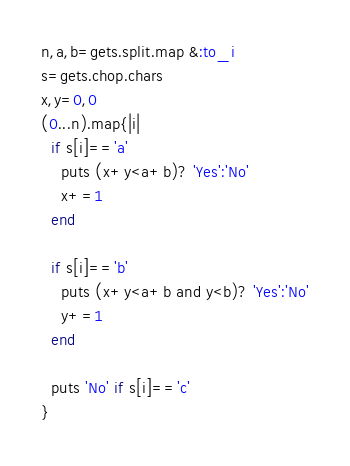Convert code to text. <code><loc_0><loc_0><loc_500><loc_500><_Ruby_>n,a,b=gets.split.map &:to_i
s=gets.chop.chars
x,y=0,0
(0...n).map{|i|
  if s[i]=='a'
    puts (x+y<a+b)? 'Yes':'No'
    x+=1
  end

  if s[i]=='b'
    puts (x+y<a+b and y<b)? 'Yes':'No'
    y+=1
  end

  puts 'No' if s[i]=='c'
}</code> 